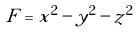Convert formula to latex. <formula><loc_0><loc_0><loc_500><loc_500>F = x ^ { 2 } - y ^ { 2 } - z ^ { 2 }</formula> 